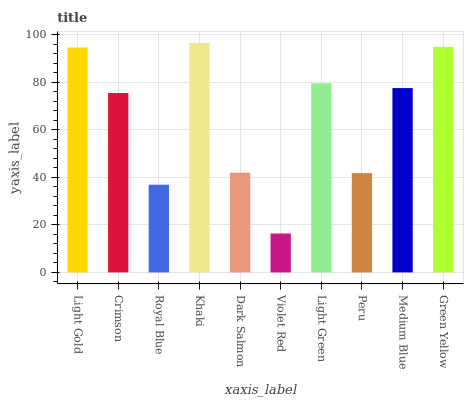Is Crimson the minimum?
Answer yes or no. No. Is Crimson the maximum?
Answer yes or no. No. Is Light Gold greater than Crimson?
Answer yes or no. Yes. Is Crimson less than Light Gold?
Answer yes or no. Yes. Is Crimson greater than Light Gold?
Answer yes or no. No. Is Light Gold less than Crimson?
Answer yes or no. No. Is Medium Blue the high median?
Answer yes or no. Yes. Is Crimson the low median?
Answer yes or no. Yes. Is Violet Red the high median?
Answer yes or no. No. Is Khaki the low median?
Answer yes or no. No. 